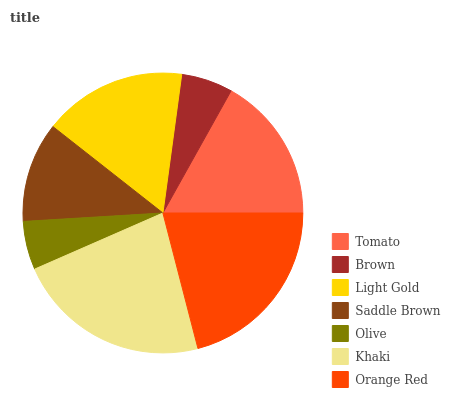Is Olive the minimum?
Answer yes or no. Yes. Is Khaki the maximum?
Answer yes or no. Yes. Is Brown the minimum?
Answer yes or no. No. Is Brown the maximum?
Answer yes or no. No. Is Tomato greater than Brown?
Answer yes or no. Yes. Is Brown less than Tomato?
Answer yes or no. Yes. Is Brown greater than Tomato?
Answer yes or no. No. Is Tomato less than Brown?
Answer yes or no. No. Is Light Gold the high median?
Answer yes or no. Yes. Is Light Gold the low median?
Answer yes or no. Yes. Is Khaki the high median?
Answer yes or no. No. Is Brown the low median?
Answer yes or no. No. 